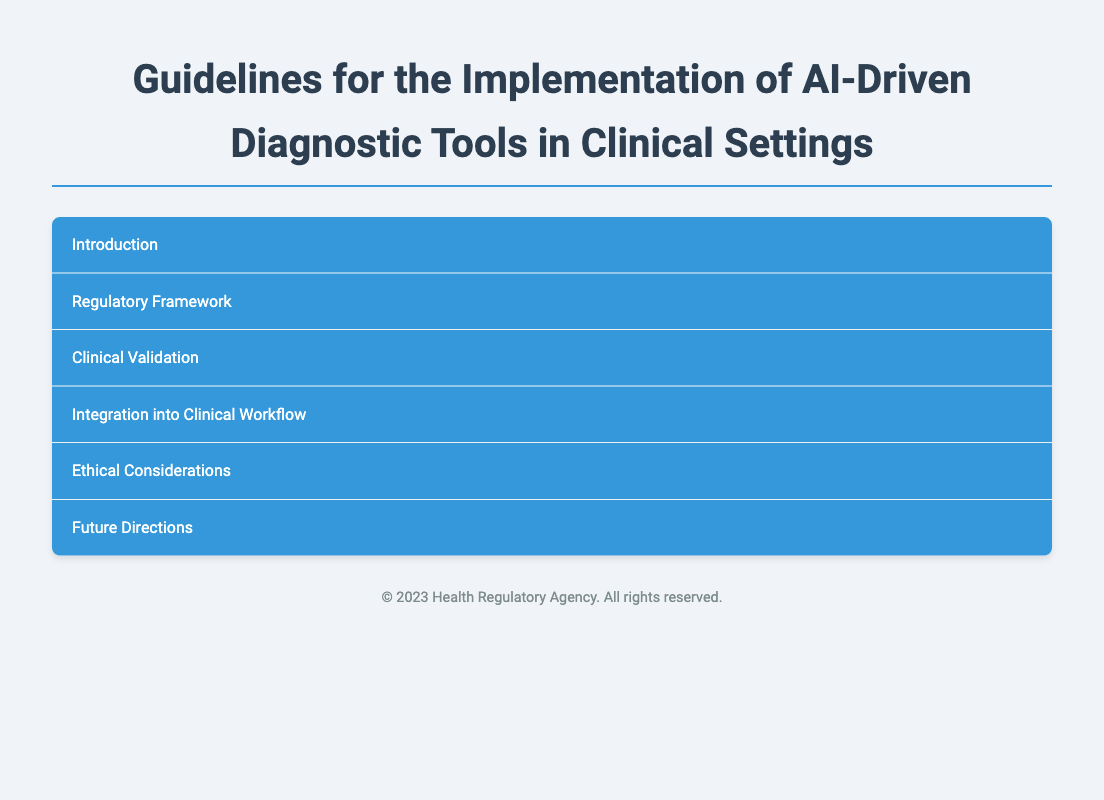What is the title of the document? The title is prominently displayed as the main heading of the document.
Answer: Guidelines for the Implementation of AI-Driven Diagnostic Tools in Clinical Settings What regulatory framework is discussed in the document? The document specifies the framework by highlighting regulatory bodies relevant to AI medical devices.
Answer: Regulatory Framework What are the two subsections under the Regulatory Framework? The subsections are listed under the main heading related to regulations for AI diagnostics.
Answer: FDA Guidance, EU Medical Device Regulation (MDR) What is emphasized for AI tool validation in clinical environments? The document outlines the strategies and considerations for validating AI tools effectively.
Answer: Real-world evidence studies and diverse datasets Which interoperability standards are mentioned? The document specifies the standards that need to be followed for operational compatibility.
Answer: HL7 and FHIR standards What is one of the ethical considerations discussed? The document mentions ethical implications related to the implementation of AI tools in diagnostics.
Answer: Bias mitigation What insight does the document provide in the Future Directions section? It highlights emerging trends and advancements in AI diagnostics.
Answer: Continuous learning systems improving diagnostic accuracy What is the primary focus of the Integration into Clinical Workflow section? This section discusses how AI tools can be effectively integrated into existing clinical practices.
Answer: User training and education 